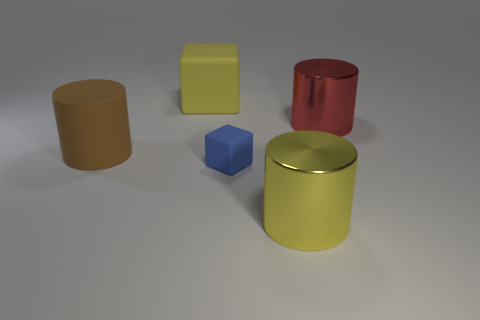How many objects are there in total and what are their colors? There are five objects in total, and their colors are as follows: one large yellow cylinder, one red cylinder, one blue cube, and two smaller cylinders, one of which is tan and one that is a muted yellow. 